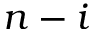<formula> <loc_0><loc_0><loc_500><loc_500>n - i</formula> 